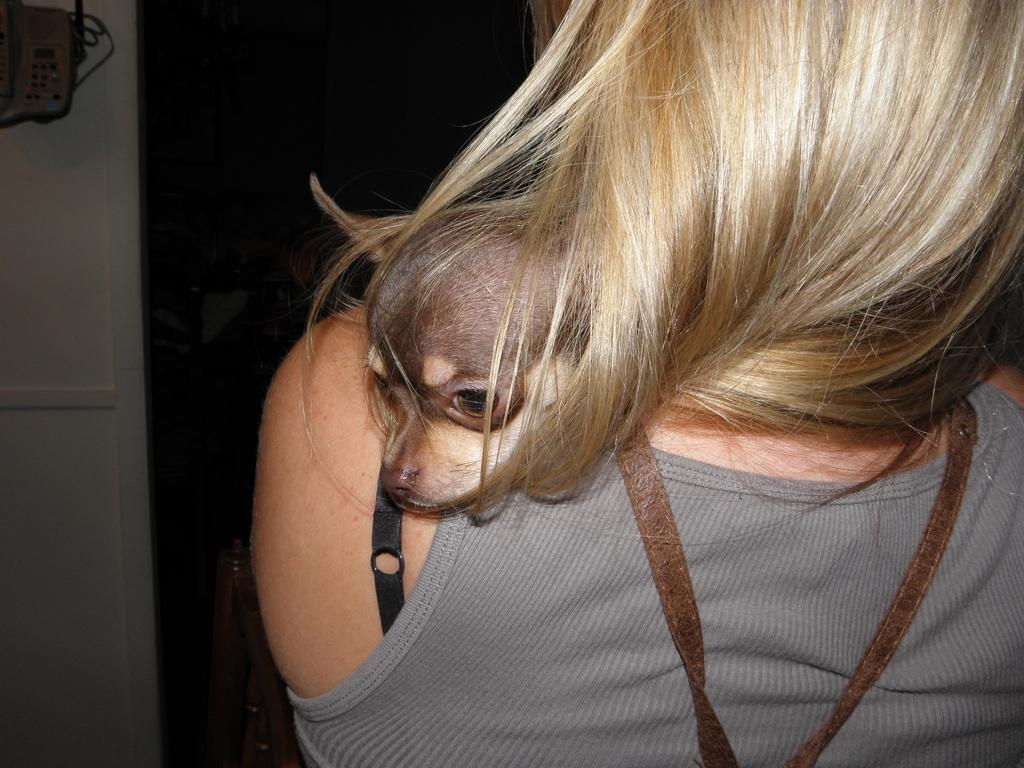Who or what is present in the image? There is a person and a dog in the image. What can be seen in the background of the image? There is a wall and wooden objects in the background of the image. What type of form or page can be seen in the image? There is no form or page present in the image; it features a person, a dog, a wall, and wooden objects. 